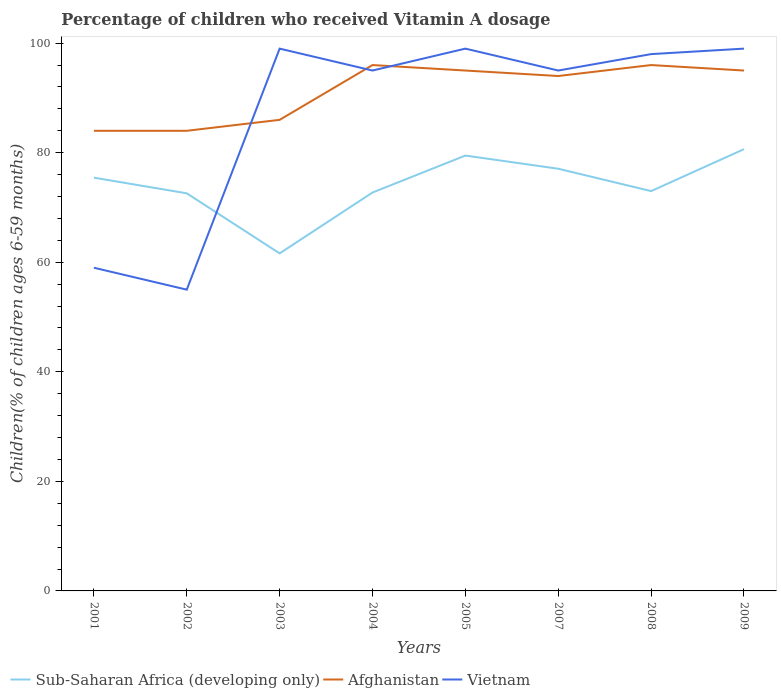How many different coloured lines are there?
Provide a short and direct response. 3. Is the number of lines equal to the number of legend labels?
Your answer should be compact. Yes. Across all years, what is the maximum percentage of children who received Vitamin A dosage in Vietnam?
Make the answer very short. 55. What is the total percentage of children who received Vitamin A dosage in Sub-Saharan Africa (developing only) in the graph?
Keep it short and to the point. -4.34. What is the difference between the highest and the second highest percentage of children who received Vitamin A dosage in Vietnam?
Your answer should be very brief. 44. Is the percentage of children who received Vitamin A dosage in Afghanistan strictly greater than the percentage of children who received Vitamin A dosage in Vietnam over the years?
Offer a very short reply. No. What is the difference between two consecutive major ticks on the Y-axis?
Your answer should be very brief. 20. What is the title of the graph?
Your response must be concise. Percentage of children who received Vitamin A dosage. What is the label or title of the X-axis?
Offer a very short reply. Years. What is the label or title of the Y-axis?
Ensure brevity in your answer.  Children(% of children ages 6-59 months). What is the Children(% of children ages 6-59 months) in Sub-Saharan Africa (developing only) in 2001?
Offer a very short reply. 75.44. What is the Children(% of children ages 6-59 months) of Afghanistan in 2001?
Provide a short and direct response. 84. What is the Children(% of children ages 6-59 months) in Vietnam in 2001?
Make the answer very short. 59. What is the Children(% of children ages 6-59 months) of Sub-Saharan Africa (developing only) in 2002?
Your answer should be compact. 72.58. What is the Children(% of children ages 6-59 months) of Sub-Saharan Africa (developing only) in 2003?
Your answer should be compact. 61.62. What is the Children(% of children ages 6-59 months) of Sub-Saharan Africa (developing only) in 2004?
Give a very brief answer. 72.73. What is the Children(% of children ages 6-59 months) in Afghanistan in 2004?
Offer a very short reply. 96. What is the Children(% of children ages 6-59 months) of Vietnam in 2004?
Ensure brevity in your answer.  95. What is the Children(% of children ages 6-59 months) in Sub-Saharan Africa (developing only) in 2005?
Your response must be concise. 79.48. What is the Children(% of children ages 6-59 months) of Sub-Saharan Africa (developing only) in 2007?
Keep it short and to the point. 77.07. What is the Children(% of children ages 6-59 months) in Afghanistan in 2007?
Give a very brief answer. 94. What is the Children(% of children ages 6-59 months) in Sub-Saharan Africa (developing only) in 2008?
Ensure brevity in your answer.  72.99. What is the Children(% of children ages 6-59 months) in Afghanistan in 2008?
Keep it short and to the point. 96. What is the Children(% of children ages 6-59 months) in Sub-Saharan Africa (developing only) in 2009?
Offer a very short reply. 80.65. What is the Children(% of children ages 6-59 months) of Afghanistan in 2009?
Your answer should be very brief. 95. What is the Children(% of children ages 6-59 months) of Vietnam in 2009?
Your response must be concise. 99. Across all years, what is the maximum Children(% of children ages 6-59 months) in Sub-Saharan Africa (developing only)?
Offer a very short reply. 80.65. Across all years, what is the maximum Children(% of children ages 6-59 months) in Afghanistan?
Ensure brevity in your answer.  96. Across all years, what is the minimum Children(% of children ages 6-59 months) of Sub-Saharan Africa (developing only)?
Your answer should be compact. 61.62. Across all years, what is the minimum Children(% of children ages 6-59 months) of Vietnam?
Offer a very short reply. 55. What is the total Children(% of children ages 6-59 months) of Sub-Saharan Africa (developing only) in the graph?
Provide a succinct answer. 592.56. What is the total Children(% of children ages 6-59 months) in Afghanistan in the graph?
Make the answer very short. 730. What is the total Children(% of children ages 6-59 months) of Vietnam in the graph?
Offer a terse response. 699. What is the difference between the Children(% of children ages 6-59 months) of Sub-Saharan Africa (developing only) in 2001 and that in 2002?
Give a very brief answer. 2.86. What is the difference between the Children(% of children ages 6-59 months) in Sub-Saharan Africa (developing only) in 2001 and that in 2003?
Your answer should be very brief. 13.83. What is the difference between the Children(% of children ages 6-59 months) in Sub-Saharan Africa (developing only) in 2001 and that in 2004?
Provide a short and direct response. 2.71. What is the difference between the Children(% of children ages 6-59 months) of Afghanistan in 2001 and that in 2004?
Your answer should be compact. -12. What is the difference between the Children(% of children ages 6-59 months) in Vietnam in 2001 and that in 2004?
Provide a succinct answer. -36. What is the difference between the Children(% of children ages 6-59 months) in Sub-Saharan Africa (developing only) in 2001 and that in 2005?
Offer a terse response. -4.03. What is the difference between the Children(% of children ages 6-59 months) in Afghanistan in 2001 and that in 2005?
Your response must be concise. -11. What is the difference between the Children(% of children ages 6-59 months) in Sub-Saharan Africa (developing only) in 2001 and that in 2007?
Keep it short and to the point. -1.63. What is the difference between the Children(% of children ages 6-59 months) in Afghanistan in 2001 and that in 2007?
Make the answer very short. -10. What is the difference between the Children(% of children ages 6-59 months) in Vietnam in 2001 and that in 2007?
Offer a terse response. -36. What is the difference between the Children(% of children ages 6-59 months) of Sub-Saharan Africa (developing only) in 2001 and that in 2008?
Ensure brevity in your answer.  2.45. What is the difference between the Children(% of children ages 6-59 months) in Vietnam in 2001 and that in 2008?
Provide a succinct answer. -39. What is the difference between the Children(% of children ages 6-59 months) in Sub-Saharan Africa (developing only) in 2001 and that in 2009?
Your response must be concise. -5.2. What is the difference between the Children(% of children ages 6-59 months) of Vietnam in 2001 and that in 2009?
Your answer should be compact. -40. What is the difference between the Children(% of children ages 6-59 months) in Sub-Saharan Africa (developing only) in 2002 and that in 2003?
Your answer should be very brief. 10.96. What is the difference between the Children(% of children ages 6-59 months) of Vietnam in 2002 and that in 2003?
Offer a terse response. -44. What is the difference between the Children(% of children ages 6-59 months) of Sub-Saharan Africa (developing only) in 2002 and that in 2004?
Your response must be concise. -0.15. What is the difference between the Children(% of children ages 6-59 months) of Sub-Saharan Africa (developing only) in 2002 and that in 2005?
Give a very brief answer. -6.9. What is the difference between the Children(% of children ages 6-59 months) in Afghanistan in 2002 and that in 2005?
Your response must be concise. -11. What is the difference between the Children(% of children ages 6-59 months) of Vietnam in 2002 and that in 2005?
Your answer should be compact. -44. What is the difference between the Children(% of children ages 6-59 months) of Sub-Saharan Africa (developing only) in 2002 and that in 2007?
Your answer should be very brief. -4.49. What is the difference between the Children(% of children ages 6-59 months) of Afghanistan in 2002 and that in 2007?
Offer a very short reply. -10. What is the difference between the Children(% of children ages 6-59 months) of Vietnam in 2002 and that in 2007?
Provide a short and direct response. -40. What is the difference between the Children(% of children ages 6-59 months) of Sub-Saharan Africa (developing only) in 2002 and that in 2008?
Keep it short and to the point. -0.41. What is the difference between the Children(% of children ages 6-59 months) of Vietnam in 2002 and that in 2008?
Offer a very short reply. -43. What is the difference between the Children(% of children ages 6-59 months) in Sub-Saharan Africa (developing only) in 2002 and that in 2009?
Make the answer very short. -8.06. What is the difference between the Children(% of children ages 6-59 months) in Vietnam in 2002 and that in 2009?
Keep it short and to the point. -44. What is the difference between the Children(% of children ages 6-59 months) of Sub-Saharan Africa (developing only) in 2003 and that in 2004?
Provide a short and direct response. -11.11. What is the difference between the Children(% of children ages 6-59 months) in Afghanistan in 2003 and that in 2004?
Make the answer very short. -10. What is the difference between the Children(% of children ages 6-59 months) in Sub-Saharan Africa (developing only) in 2003 and that in 2005?
Keep it short and to the point. -17.86. What is the difference between the Children(% of children ages 6-59 months) of Vietnam in 2003 and that in 2005?
Your response must be concise. 0. What is the difference between the Children(% of children ages 6-59 months) in Sub-Saharan Africa (developing only) in 2003 and that in 2007?
Provide a short and direct response. -15.45. What is the difference between the Children(% of children ages 6-59 months) of Afghanistan in 2003 and that in 2007?
Ensure brevity in your answer.  -8. What is the difference between the Children(% of children ages 6-59 months) of Sub-Saharan Africa (developing only) in 2003 and that in 2008?
Your answer should be very brief. -11.37. What is the difference between the Children(% of children ages 6-59 months) of Afghanistan in 2003 and that in 2008?
Offer a very short reply. -10. What is the difference between the Children(% of children ages 6-59 months) in Sub-Saharan Africa (developing only) in 2003 and that in 2009?
Provide a short and direct response. -19.03. What is the difference between the Children(% of children ages 6-59 months) in Vietnam in 2003 and that in 2009?
Offer a terse response. 0. What is the difference between the Children(% of children ages 6-59 months) of Sub-Saharan Africa (developing only) in 2004 and that in 2005?
Offer a terse response. -6.75. What is the difference between the Children(% of children ages 6-59 months) of Afghanistan in 2004 and that in 2005?
Keep it short and to the point. 1. What is the difference between the Children(% of children ages 6-59 months) of Vietnam in 2004 and that in 2005?
Your response must be concise. -4. What is the difference between the Children(% of children ages 6-59 months) of Sub-Saharan Africa (developing only) in 2004 and that in 2007?
Keep it short and to the point. -4.34. What is the difference between the Children(% of children ages 6-59 months) in Afghanistan in 2004 and that in 2007?
Give a very brief answer. 2. What is the difference between the Children(% of children ages 6-59 months) in Sub-Saharan Africa (developing only) in 2004 and that in 2008?
Your answer should be very brief. -0.26. What is the difference between the Children(% of children ages 6-59 months) in Vietnam in 2004 and that in 2008?
Your response must be concise. -3. What is the difference between the Children(% of children ages 6-59 months) of Sub-Saharan Africa (developing only) in 2004 and that in 2009?
Your response must be concise. -7.92. What is the difference between the Children(% of children ages 6-59 months) of Vietnam in 2004 and that in 2009?
Provide a short and direct response. -4. What is the difference between the Children(% of children ages 6-59 months) of Sub-Saharan Africa (developing only) in 2005 and that in 2007?
Your answer should be very brief. 2.41. What is the difference between the Children(% of children ages 6-59 months) in Vietnam in 2005 and that in 2007?
Keep it short and to the point. 4. What is the difference between the Children(% of children ages 6-59 months) of Sub-Saharan Africa (developing only) in 2005 and that in 2008?
Your answer should be compact. 6.49. What is the difference between the Children(% of children ages 6-59 months) of Afghanistan in 2005 and that in 2008?
Your answer should be compact. -1. What is the difference between the Children(% of children ages 6-59 months) in Sub-Saharan Africa (developing only) in 2005 and that in 2009?
Provide a succinct answer. -1.17. What is the difference between the Children(% of children ages 6-59 months) of Sub-Saharan Africa (developing only) in 2007 and that in 2008?
Ensure brevity in your answer.  4.08. What is the difference between the Children(% of children ages 6-59 months) in Afghanistan in 2007 and that in 2008?
Ensure brevity in your answer.  -2. What is the difference between the Children(% of children ages 6-59 months) in Sub-Saharan Africa (developing only) in 2007 and that in 2009?
Offer a very short reply. -3.58. What is the difference between the Children(% of children ages 6-59 months) of Vietnam in 2007 and that in 2009?
Offer a terse response. -4. What is the difference between the Children(% of children ages 6-59 months) of Sub-Saharan Africa (developing only) in 2008 and that in 2009?
Offer a terse response. -7.66. What is the difference between the Children(% of children ages 6-59 months) of Afghanistan in 2008 and that in 2009?
Your response must be concise. 1. What is the difference between the Children(% of children ages 6-59 months) of Vietnam in 2008 and that in 2009?
Your answer should be compact. -1. What is the difference between the Children(% of children ages 6-59 months) in Sub-Saharan Africa (developing only) in 2001 and the Children(% of children ages 6-59 months) in Afghanistan in 2002?
Ensure brevity in your answer.  -8.56. What is the difference between the Children(% of children ages 6-59 months) of Sub-Saharan Africa (developing only) in 2001 and the Children(% of children ages 6-59 months) of Vietnam in 2002?
Provide a succinct answer. 20.44. What is the difference between the Children(% of children ages 6-59 months) of Afghanistan in 2001 and the Children(% of children ages 6-59 months) of Vietnam in 2002?
Ensure brevity in your answer.  29. What is the difference between the Children(% of children ages 6-59 months) in Sub-Saharan Africa (developing only) in 2001 and the Children(% of children ages 6-59 months) in Afghanistan in 2003?
Ensure brevity in your answer.  -10.56. What is the difference between the Children(% of children ages 6-59 months) of Sub-Saharan Africa (developing only) in 2001 and the Children(% of children ages 6-59 months) of Vietnam in 2003?
Your answer should be compact. -23.56. What is the difference between the Children(% of children ages 6-59 months) of Afghanistan in 2001 and the Children(% of children ages 6-59 months) of Vietnam in 2003?
Ensure brevity in your answer.  -15. What is the difference between the Children(% of children ages 6-59 months) of Sub-Saharan Africa (developing only) in 2001 and the Children(% of children ages 6-59 months) of Afghanistan in 2004?
Your answer should be compact. -20.56. What is the difference between the Children(% of children ages 6-59 months) in Sub-Saharan Africa (developing only) in 2001 and the Children(% of children ages 6-59 months) in Vietnam in 2004?
Offer a terse response. -19.56. What is the difference between the Children(% of children ages 6-59 months) of Sub-Saharan Africa (developing only) in 2001 and the Children(% of children ages 6-59 months) of Afghanistan in 2005?
Your answer should be very brief. -19.56. What is the difference between the Children(% of children ages 6-59 months) in Sub-Saharan Africa (developing only) in 2001 and the Children(% of children ages 6-59 months) in Vietnam in 2005?
Keep it short and to the point. -23.56. What is the difference between the Children(% of children ages 6-59 months) in Sub-Saharan Africa (developing only) in 2001 and the Children(% of children ages 6-59 months) in Afghanistan in 2007?
Offer a very short reply. -18.56. What is the difference between the Children(% of children ages 6-59 months) of Sub-Saharan Africa (developing only) in 2001 and the Children(% of children ages 6-59 months) of Vietnam in 2007?
Your response must be concise. -19.56. What is the difference between the Children(% of children ages 6-59 months) of Afghanistan in 2001 and the Children(% of children ages 6-59 months) of Vietnam in 2007?
Offer a terse response. -11. What is the difference between the Children(% of children ages 6-59 months) of Sub-Saharan Africa (developing only) in 2001 and the Children(% of children ages 6-59 months) of Afghanistan in 2008?
Offer a terse response. -20.56. What is the difference between the Children(% of children ages 6-59 months) in Sub-Saharan Africa (developing only) in 2001 and the Children(% of children ages 6-59 months) in Vietnam in 2008?
Offer a terse response. -22.56. What is the difference between the Children(% of children ages 6-59 months) of Sub-Saharan Africa (developing only) in 2001 and the Children(% of children ages 6-59 months) of Afghanistan in 2009?
Keep it short and to the point. -19.56. What is the difference between the Children(% of children ages 6-59 months) in Sub-Saharan Africa (developing only) in 2001 and the Children(% of children ages 6-59 months) in Vietnam in 2009?
Offer a terse response. -23.56. What is the difference between the Children(% of children ages 6-59 months) in Sub-Saharan Africa (developing only) in 2002 and the Children(% of children ages 6-59 months) in Afghanistan in 2003?
Make the answer very short. -13.42. What is the difference between the Children(% of children ages 6-59 months) of Sub-Saharan Africa (developing only) in 2002 and the Children(% of children ages 6-59 months) of Vietnam in 2003?
Provide a short and direct response. -26.42. What is the difference between the Children(% of children ages 6-59 months) of Afghanistan in 2002 and the Children(% of children ages 6-59 months) of Vietnam in 2003?
Offer a terse response. -15. What is the difference between the Children(% of children ages 6-59 months) of Sub-Saharan Africa (developing only) in 2002 and the Children(% of children ages 6-59 months) of Afghanistan in 2004?
Your answer should be compact. -23.42. What is the difference between the Children(% of children ages 6-59 months) of Sub-Saharan Africa (developing only) in 2002 and the Children(% of children ages 6-59 months) of Vietnam in 2004?
Your answer should be compact. -22.42. What is the difference between the Children(% of children ages 6-59 months) in Sub-Saharan Africa (developing only) in 2002 and the Children(% of children ages 6-59 months) in Afghanistan in 2005?
Ensure brevity in your answer.  -22.42. What is the difference between the Children(% of children ages 6-59 months) of Sub-Saharan Africa (developing only) in 2002 and the Children(% of children ages 6-59 months) of Vietnam in 2005?
Make the answer very short. -26.42. What is the difference between the Children(% of children ages 6-59 months) of Afghanistan in 2002 and the Children(% of children ages 6-59 months) of Vietnam in 2005?
Your answer should be compact. -15. What is the difference between the Children(% of children ages 6-59 months) in Sub-Saharan Africa (developing only) in 2002 and the Children(% of children ages 6-59 months) in Afghanistan in 2007?
Your answer should be very brief. -21.42. What is the difference between the Children(% of children ages 6-59 months) of Sub-Saharan Africa (developing only) in 2002 and the Children(% of children ages 6-59 months) of Vietnam in 2007?
Provide a succinct answer. -22.42. What is the difference between the Children(% of children ages 6-59 months) in Sub-Saharan Africa (developing only) in 2002 and the Children(% of children ages 6-59 months) in Afghanistan in 2008?
Offer a terse response. -23.42. What is the difference between the Children(% of children ages 6-59 months) of Sub-Saharan Africa (developing only) in 2002 and the Children(% of children ages 6-59 months) of Vietnam in 2008?
Make the answer very short. -25.42. What is the difference between the Children(% of children ages 6-59 months) of Sub-Saharan Africa (developing only) in 2002 and the Children(% of children ages 6-59 months) of Afghanistan in 2009?
Provide a short and direct response. -22.42. What is the difference between the Children(% of children ages 6-59 months) in Sub-Saharan Africa (developing only) in 2002 and the Children(% of children ages 6-59 months) in Vietnam in 2009?
Provide a succinct answer. -26.42. What is the difference between the Children(% of children ages 6-59 months) of Sub-Saharan Africa (developing only) in 2003 and the Children(% of children ages 6-59 months) of Afghanistan in 2004?
Provide a succinct answer. -34.38. What is the difference between the Children(% of children ages 6-59 months) in Sub-Saharan Africa (developing only) in 2003 and the Children(% of children ages 6-59 months) in Vietnam in 2004?
Offer a terse response. -33.38. What is the difference between the Children(% of children ages 6-59 months) in Afghanistan in 2003 and the Children(% of children ages 6-59 months) in Vietnam in 2004?
Provide a succinct answer. -9. What is the difference between the Children(% of children ages 6-59 months) in Sub-Saharan Africa (developing only) in 2003 and the Children(% of children ages 6-59 months) in Afghanistan in 2005?
Keep it short and to the point. -33.38. What is the difference between the Children(% of children ages 6-59 months) of Sub-Saharan Africa (developing only) in 2003 and the Children(% of children ages 6-59 months) of Vietnam in 2005?
Provide a short and direct response. -37.38. What is the difference between the Children(% of children ages 6-59 months) of Sub-Saharan Africa (developing only) in 2003 and the Children(% of children ages 6-59 months) of Afghanistan in 2007?
Your answer should be very brief. -32.38. What is the difference between the Children(% of children ages 6-59 months) in Sub-Saharan Africa (developing only) in 2003 and the Children(% of children ages 6-59 months) in Vietnam in 2007?
Your answer should be very brief. -33.38. What is the difference between the Children(% of children ages 6-59 months) of Afghanistan in 2003 and the Children(% of children ages 6-59 months) of Vietnam in 2007?
Ensure brevity in your answer.  -9. What is the difference between the Children(% of children ages 6-59 months) in Sub-Saharan Africa (developing only) in 2003 and the Children(% of children ages 6-59 months) in Afghanistan in 2008?
Make the answer very short. -34.38. What is the difference between the Children(% of children ages 6-59 months) in Sub-Saharan Africa (developing only) in 2003 and the Children(% of children ages 6-59 months) in Vietnam in 2008?
Provide a succinct answer. -36.38. What is the difference between the Children(% of children ages 6-59 months) of Afghanistan in 2003 and the Children(% of children ages 6-59 months) of Vietnam in 2008?
Give a very brief answer. -12. What is the difference between the Children(% of children ages 6-59 months) in Sub-Saharan Africa (developing only) in 2003 and the Children(% of children ages 6-59 months) in Afghanistan in 2009?
Offer a terse response. -33.38. What is the difference between the Children(% of children ages 6-59 months) in Sub-Saharan Africa (developing only) in 2003 and the Children(% of children ages 6-59 months) in Vietnam in 2009?
Keep it short and to the point. -37.38. What is the difference between the Children(% of children ages 6-59 months) in Afghanistan in 2003 and the Children(% of children ages 6-59 months) in Vietnam in 2009?
Your answer should be compact. -13. What is the difference between the Children(% of children ages 6-59 months) of Sub-Saharan Africa (developing only) in 2004 and the Children(% of children ages 6-59 months) of Afghanistan in 2005?
Your answer should be compact. -22.27. What is the difference between the Children(% of children ages 6-59 months) of Sub-Saharan Africa (developing only) in 2004 and the Children(% of children ages 6-59 months) of Vietnam in 2005?
Make the answer very short. -26.27. What is the difference between the Children(% of children ages 6-59 months) in Afghanistan in 2004 and the Children(% of children ages 6-59 months) in Vietnam in 2005?
Your answer should be very brief. -3. What is the difference between the Children(% of children ages 6-59 months) in Sub-Saharan Africa (developing only) in 2004 and the Children(% of children ages 6-59 months) in Afghanistan in 2007?
Provide a succinct answer. -21.27. What is the difference between the Children(% of children ages 6-59 months) in Sub-Saharan Africa (developing only) in 2004 and the Children(% of children ages 6-59 months) in Vietnam in 2007?
Ensure brevity in your answer.  -22.27. What is the difference between the Children(% of children ages 6-59 months) of Afghanistan in 2004 and the Children(% of children ages 6-59 months) of Vietnam in 2007?
Your answer should be very brief. 1. What is the difference between the Children(% of children ages 6-59 months) of Sub-Saharan Africa (developing only) in 2004 and the Children(% of children ages 6-59 months) of Afghanistan in 2008?
Your answer should be compact. -23.27. What is the difference between the Children(% of children ages 6-59 months) of Sub-Saharan Africa (developing only) in 2004 and the Children(% of children ages 6-59 months) of Vietnam in 2008?
Your answer should be very brief. -25.27. What is the difference between the Children(% of children ages 6-59 months) of Sub-Saharan Africa (developing only) in 2004 and the Children(% of children ages 6-59 months) of Afghanistan in 2009?
Ensure brevity in your answer.  -22.27. What is the difference between the Children(% of children ages 6-59 months) in Sub-Saharan Africa (developing only) in 2004 and the Children(% of children ages 6-59 months) in Vietnam in 2009?
Your answer should be very brief. -26.27. What is the difference between the Children(% of children ages 6-59 months) in Sub-Saharan Africa (developing only) in 2005 and the Children(% of children ages 6-59 months) in Afghanistan in 2007?
Provide a succinct answer. -14.52. What is the difference between the Children(% of children ages 6-59 months) in Sub-Saharan Africa (developing only) in 2005 and the Children(% of children ages 6-59 months) in Vietnam in 2007?
Your answer should be compact. -15.52. What is the difference between the Children(% of children ages 6-59 months) in Sub-Saharan Africa (developing only) in 2005 and the Children(% of children ages 6-59 months) in Afghanistan in 2008?
Offer a very short reply. -16.52. What is the difference between the Children(% of children ages 6-59 months) in Sub-Saharan Africa (developing only) in 2005 and the Children(% of children ages 6-59 months) in Vietnam in 2008?
Offer a very short reply. -18.52. What is the difference between the Children(% of children ages 6-59 months) in Afghanistan in 2005 and the Children(% of children ages 6-59 months) in Vietnam in 2008?
Provide a short and direct response. -3. What is the difference between the Children(% of children ages 6-59 months) in Sub-Saharan Africa (developing only) in 2005 and the Children(% of children ages 6-59 months) in Afghanistan in 2009?
Your response must be concise. -15.52. What is the difference between the Children(% of children ages 6-59 months) in Sub-Saharan Africa (developing only) in 2005 and the Children(% of children ages 6-59 months) in Vietnam in 2009?
Ensure brevity in your answer.  -19.52. What is the difference between the Children(% of children ages 6-59 months) of Sub-Saharan Africa (developing only) in 2007 and the Children(% of children ages 6-59 months) of Afghanistan in 2008?
Provide a succinct answer. -18.93. What is the difference between the Children(% of children ages 6-59 months) of Sub-Saharan Africa (developing only) in 2007 and the Children(% of children ages 6-59 months) of Vietnam in 2008?
Your response must be concise. -20.93. What is the difference between the Children(% of children ages 6-59 months) of Afghanistan in 2007 and the Children(% of children ages 6-59 months) of Vietnam in 2008?
Ensure brevity in your answer.  -4. What is the difference between the Children(% of children ages 6-59 months) of Sub-Saharan Africa (developing only) in 2007 and the Children(% of children ages 6-59 months) of Afghanistan in 2009?
Keep it short and to the point. -17.93. What is the difference between the Children(% of children ages 6-59 months) of Sub-Saharan Africa (developing only) in 2007 and the Children(% of children ages 6-59 months) of Vietnam in 2009?
Provide a succinct answer. -21.93. What is the difference between the Children(% of children ages 6-59 months) of Afghanistan in 2007 and the Children(% of children ages 6-59 months) of Vietnam in 2009?
Give a very brief answer. -5. What is the difference between the Children(% of children ages 6-59 months) in Sub-Saharan Africa (developing only) in 2008 and the Children(% of children ages 6-59 months) in Afghanistan in 2009?
Keep it short and to the point. -22.01. What is the difference between the Children(% of children ages 6-59 months) in Sub-Saharan Africa (developing only) in 2008 and the Children(% of children ages 6-59 months) in Vietnam in 2009?
Offer a very short reply. -26.01. What is the difference between the Children(% of children ages 6-59 months) of Afghanistan in 2008 and the Children(% of children ages 6-59 months) of Vietnam in 2009?
Offer a terse response. -3. What is the average Children(% of children ages 6-59 months) of Sub-Saharan Africa (developing only) per year?
Make the answer very short. 74.07. What is the average Children(% of children ages 6-59 months) of Afghanistan per year?
Provide a succinct answer. 91.25. What is the average Children(% of children ages 6-59 months) in Vietnam per year?
Keep it short and to the point. 87.38. In the year 2001, what is the difference between the Children(% of children ages 6-59 months) in Sub-Saharan Africa (developing only) and Children(% of children ages 6-59 months) in Afghanistan?
Keep it short and to the point. -8.56. In the year 2001, what is the difference between the Children(% of children ages 6-59 months) in Sub-Saharan Africa (developing only) and Children(% of children ages 6-59 months) in Vietnam?
Make the answer very short. 16.44. In the year 2002, what is the difference between the Children(% of children ages 6-59 months) in Sub-Saharan Africa (developing only) and Children(% of children ages 6-59 months) in Afghanistan?
Provide a short and direct response. -11.42. In the year 2002, what is the difference between the Children(% of children ages 6-59 months) in Sub-Saharan Africa (developing only) and Children(% of children ages 6-59 months) in Vietnam?
Keep it short and to the point. 17.58. In the year 2003, what is the difference between the Children(% of children ages 6-59 months) in Sub-Saharan Africa (developing only) and Children(% of children ages 6-59 months) in Afghanistan?
Your response must be concise. -24.38. In the year 2003, what is the difference between the Children(% of children ages 6-59 months) of Sub-Saharan Africa (developing only) and Children(% of children ages 6-59 months) of Vietnam?
Your answer should be very brief. -37.38. In the year 2004, what is the difference between the Children(% of children ages 6-59 months) of Sub-Saharan Africa (developing only) and Children(% of children ages 6-59 months) of Afghanistan?
Give a very brief answer. -23.27. In the year 2004, what is the difference between the Children(% of children ages 6-59 months) in Sub-Saharan Africa (developing only) and Children(% of children ages 6-59 months) in Vietnam?
Ensure brevity in your answer.  -22.27. In the year 2005, what is the difference between the Children(% of children ages 6-59 months) in Sub-Saharan Africa (developing only) and Children(% of children ages 6-59 months) in Afghanistan?
Make the answer very short. -15.52. In the year 2005, what is the difference between the Children(% of children ages 6-59 months) in Sub-Saharan Africa (developing only) and Children(% of children ages 6-59 months) in Vietnam?
Provide a succinct answer. -19.52. In the year 2005, what is the difference between the Children(% of children ages 6-59 months) of Afghanistan and Children(% of children ages 6-59 months) of Vietnam?
Make the answer very short. -4. In the year 2007, what is the difference between the Children(% of children ages 6-59 months) in Sub-Saharan Africa (developing only) and Children(% of children ages 6-59 months) in Afghanistan?
Provide a short and direct response. -16.93. In the year 2007, what is the difference between the Children(% of children ages 6-59 months) in Sub-Saharan Africa (developing only) and Children(% of children ages 6-59 months) in Vietnam?
Ensure brevity in your answer.  -17.93. In the year 2008, what is the difference between the Children(% of children ages 6-59 months) in Sub-Saharan Africa (developing only) and Children(% of children ages 6-59 months) in Afghanistan?
Ensure brevity in your answer.  -23.01. In the year 2008, what is the difference between the Children(% of children ages 6-59 months) of Sub-Saharan Africa (developing only) and Children(% of children ages 6-59 months) of Vietnam?
Your answer should be compact. -25.01. In the year 2009, what is the difference between the Children(% of children ages 6-59 months) in Sub-Saharan Africa (developing only) and Children(% of children ages 6-59 months) in Afghanistan?
Provide a short and direct response. -14.35. In the year 2009, what is the difference between the Children(% of children ages 6-59 months) in Sub-Saharan Africa (developing only) and Children(% of children ages 6-59 months) in Vietnam?
Your answer should be compact. -18.35. In the year 2009, what is the difference between the Children(% of children ages 6-59 months) in Afghanistan and Children(% of children ages 6-59 months) in Vietnam?
Keep it short and to the point. -4. What is the ratio of the Children(% of children ages 6-59 months) of Sub-Saharan Africa (developing only) in 2001 to that in 2002?
Provide a short and direct response. 1.04. What is the ratio of the Children(% of children ages 6-59 months) of Afghanistan in 2001 to that in 2002?
Provide a succinct answer. 1. What is the ratio of the Children(% of children ages 6-59 months) in Vietnam in 2001 to that in 2002?
Provide a short and direct response. 1.07. What is the ratio of the Children(% of children ages 6-59 months) of Sub-Saharan Africa (developing only) in 2001 to that in 2003?
Your response must be concise. 1.22. What is the ratio of the Children(% of children ages 6-59 months) of Afghanistan in 2001 to that in 2003?
Your answer should be very brief. 0.98. What is the ratio of the Children(% of children ages 6-59 months) in Vietnam in 2001 to that in 2003?
Your answer should be very brief. 0.6. What is the ratio of the Children(% of children ages 6-59 months) of Sub-Saharan Africa (developing only) in 2001 to that in 2004?
Your answer should be very brief. 1.04. What is the ratio of the Children(% of children ages 6-59 months) in Afghanistan in 2001 to that in 2004?
Your answer should be very brief. 0.88. What is the ratio of the Children(% of children ages 6-59 months) in Vietnam in 2001 to that in 2004?
Your response must be concise. 0.62. What is the ratio of the Children(% of children ages 6-59 months) in Sub-Saharan Africa (developing only) in 2001 to that in 2005?
Your answer should be compact. 0.95. What is the ratio of the Children(% of children ages 6-59 months) in Afghanistan in 2001 to that in 2005?
Your answer should be very brief. 0.88. What is the ratio of the Children(% of children ages 6-59 months) of Vietnam in 2001 to that in 2005?
Your answer should be very brief. 0.6. What is the ratio of the Children(% of children ages 6-59 months) of Sub-Saharan Africa (developing only) in 2001 to that in 2007?
Provide a short and direct response. 0.98. What is the ratio of the Children(% of children ages 6-59 months) in Afghanistan in 2001 to that in 2007?
Give a very brief answer. 0.89. What is the ratio of the Children(% of children ages 6-59 months) in Vietnam in 2001 to that in 2007?
Provide a succinct answer. 0.62. What is the ratio of the Children(% of children ages 6-59 months) in Sub-Saharan Africa (developing only) in 2001 to that in 2008?
Offer a terse response. 1.03. What is the ratio of the Children(% of children ages 6-59 months) in Afghanistan in 2001 to that in 2008?
Provide a short and direct response. 0.88. What is the ratio of the Children(% of children ages 6-59 months) in Vietnam in 2001 to that in 2008?
Provide a short and direct response. 0.6. What is the ratio of the Children(% of children ages 6-59 months) in Sub-Saharan Africa (developing only) in 2001 to that in 2009?
Provide a short and direct response. 0.94. What is the ratio of the Children(% of children ages 6-59 months) in Afghanistan in 2001 to that in 2009?
Provide a succinct answer. 0.88. What is the ratio of the Children(% of children ages 6-59 months) in Vietnam in 2001 to that in 2009?
Make the answer very short. 0.6. What is the ratio of the Children(% of children ages 6-59 months) in Sub-Saharan Africa (developing only) in 2002 to that in 2003?
Your answer should be compact. 1.18. What is the ratio of the Children(% of children ages 6-59 months) in Afghanistan in 2002 to that in 2003?
Provide a short and direct response. 0.98. What is the ratio of the Children(% of children ages 6-59 months) in Vietnam in 2002 to that in 2003?
Your answer should be compact. 0.56. What is the ratio of the Children(% of children ages 6-59 months) in Vietnam in 2002 to that in 2004?
Provide a succinct answer. 0.58. What is the ratio of the Children(% of children ages 6-59 months) of Sub-Saharan Africa (developing only) in 2002 to that in 2005?
Provide a short and direct response. 0.91. What is the ratio of the Children(% of children ages 6-59 months) in Afghanistan in 2002 to that in 2005?
Provide a succinct answer. 0.88. What is the ratio of the Children(% of children ages 6-59 months) of Vietnam in 2002 to that in 2005?
Provide a succinct answer. 0.56. What is the ratio of the Children(% of children ages 6-59 months) of Sub-Saharan Africa (developing only) in 2002 to that in 2007?
Keep it short and to the point. 0.94. What is the ratio of the Children(% of children ages 6-59 months) of Afghanistan in 2002 to that in 2007?
Your answer should be very brief. 0.89. What is the ratio of the Children(% of children ages 6-59 months) of Vietnam in 2002 to that in 2007?
Offer a terse response. 0.58. What is the ratio of the Children(% of children ages 6-59 months) in Vietnam in 2002 to that in 2008?
Keep it short and to the point. 0.56. What is the ratio of the Children(% of children ages 6-59 months) of Sub-Saharan Africa (developing only) in 2002 to that in 2009?
Give a very brief answer. 0.9. What is the ratio of the Children(% of children ages 6-59 months) in Afghanistan in 2002 to that in 2009?
Your answer should be very brief. 0.88. What is the ratio of the Children(% of children ages 6-59 months) in Vietnam in 2002 to that in 2009?
Your answer should be compact. 0.56. What is the ratio of the Children(% of children ages 6-59 months) in Sub-Saharan Africa (developing only) in 2003 to that in 2004?
Ensure brevity in your answer.  0.85. What is the ratio of the Children(% of children ages 6-59 months) in Afghanistan in 2003 to that in 2004?
Your answer should be compact. 0.9. What is the ratio of the Children(% of children ages 6-59 months) in Vietnam in 2003 to that in 2004?
Make the answer very short. 1.04. What is the ratio of the Children(% of children ages 6-59 months) in Sub-Saharan Africa (developing only) in 2003 to that in 2005?
Your answer should be compact. 0.78. What is the ratio of the Children(% of children ages 6-59 months) of Afghanistan in 2003 to that in 2005?
Offer a very short reply. 0.91. What is the ratio of the Children(% of children ages 6-59 months) in Sub-Saharan Africa (developing only) in 2003 to that in 2007?
Provide a short and direct response. 0.8. What is the ratio of the Children(% of children ages 6-59 months) of Afghanistan in 2003 to that in 2007?
Provide a succinct answer. 0.91. What is the ratio of the Children(% of children ages 6-59 months) of Vietnam in 2003 to that in 2007?
Your answer should be very brief. 1.04. What is the ratio of the Children(% of children ages 6-59 months) of Sub-Saharan Africa (developing only) in 2003 to that in 2008?
Ensure brevity in your answer.  0.84. What is the ratio of the Children(% of children ages 6-59 months) in Afghanistan in 2003 to that in 2008?
Provide a succinct answer. 0.9. What is the ratio of the Children(% of children ages 6-59 months) in Vietnam in 2003 to that in 2008?
Keep it short and to the point. 1.01. What is the ratio of the Children(% of children ages 6-59 months) in Sub-Saharan Africa (developing only) in 2003 to that in 2009?
Offer a very short reply. 0.76. What is the ratio of the Children(% of children ages 6-59 months) in Afghanistan in 2003 to that in 2009?
Your response must be concise. 0.91. What is the ratio of the Children(% of children ages 6-59 months) of Sub-Saharan Africa (developing only) in 2004 to that in 2005?
Your answer should be very brief. 0.92. What is the ratio of the Children(% of children ages 6-59 months) of Afghanistan in 2004 to that in 2005?
Your response must be concise. 1.01. What is the ratio of the Children(% of children ages 6-59 months) in Vietnam in 2004 to that in 2005?
Give a very brief answer. 0.96. What is the ratio of the Children(% of children ages 6-59 months) in Sub-Saharan Africa (developing only) in 2004 to that in 2007?
Keep it short and to the point. 0.94. What is the ratio of the Children(% of children ages 6-59 months) in Afghanistan in 2004 to that in 2007?
Your answer should be very brief. 1.02. What is the ratio of the Children(% of children ages 6-59 months) in Vietnam in 2004 to that in 2007?
Your answer should be very brief. 1. What is the ratio of the Children(% of children ages 6-59 months) in Sub-Saharan Africa (developing only) in 2004 to that in 2008?
Offer a terse response. 1. What is the ratio of the Children(% of children ages 6-59 months) of Afghanistan in 2004 to that in 2008?
Give a very brief answer. 1. What is the ratio of the Children(% of children ages 6-59 months) of Vietnam in 2004 to that in 2008?
Your response must be concise. 0.97. What is the ratio of the Children(% of children ages 6-59 months) in Sub-Saharan Africa (developing only) in 2004 to that in 2009?
Your response must be concise. 0.9. What is the ratio of the Children(% of children ages 6-59 months) in Afghanistan in 2004 to that in 2009?
Ensure brevity in your answer.  1.01. What is the ratio of the Children(% of children ages 6-59 months) in Vietnam in 2004 to that in 2009?
Offer a very short reply. 0.96. What is the ratio of the Children(% of children ages 6-59 months) in Sub-Saharan Africa (developing only) in 2005 to that in 2007?
Your answer should be compact. 1.03. What is the ratio of the Children(% of children ages 6-59 months) in Afghanistan in 2005 to that in 2007?
Offer a very short reply. 1.01. What is the ratio of the Children(% of children ages 6-59 months) of Vietnam in 2005 to that in 2007?
Offer a very short reply. 1.04. What is the ratio of the Children(% of children ages 6-59 months) in Sub-Saharan Africa (developing only) in 2005 to that in 2008?
Provide a succinct answer. 1.09. What is the ratio of the Children(% of children ages 6-59 months) of Afghanistan in 2005 to that in 2008?
Ensure brevity in your answer.  0.99. What is the ratio of the Children(% of children ages 6-59 months) of Vietnam in 2005 to that in 2008?
Ensure brevity in your answer.  1.01. What is the ratio of the Children(% of children ages 6-59 months) in Sub-Saharan Africa (developing only) in 2005 to that in 2009?
Provide a succinct answer. 0.99. What is the ratio of the Children(% of children ages 6-59 months) of Afghanistan in 2005 to that in 2009?
Your answer should be compact. 1. What is the ratio of the Children(% of children ages 6-59 months) of Vietnam in 2005 to that in 2009?
Ensure brevity in your answer.  1. What is the ratio of the Children(% of children ages 6-59 months) of Sub-Saharan Africa (developing only) in 2007 to that in 2008?
Offer a very short reply. 1.06. What is the ratio of the Children(% of children ages 6-59 months) of Afghanistan in 2007 to that in 2008?
Your response must be concise. 0.98. What is the ratio of the Children(% of children ages 6-59 months) in Vietnam in 2007 to that in 2008?
Offer a terse response. 0.97. What is the ratio of the Children(% of children ages 6-59 months) of Sub-Saharan Africa (developing only) in 2007 to that in 2009?
Provide a short and direct response. 0.96. What is the ratio of the Children(% of children ages 6-59 months) of Afghanistan in 2007 to that in 2009?
Make the answer very short. 0.99. What is the ratio of the Children(% of children ages 6-59 months) in Vietnam in 2007 to that in 2009?
Provide a succinct answer. 0.96. What is the ratio of the Children(% of children ages 6-59 months) of Sub-Saharan Africa (developing only) in 2008 to that in 2009?
Offer a very short reply. 0.91. What is the ratio of the Children(% of children ages 6-59 months) in Afghanistan in 2008 to that in 2009?
Offer a terse response. 1.01. What is the ratio of the Children(% of children ages 6-59 months) of Vietnam in 2008 to that in 2009?
Your response must be concise. 0.99. What is the difference between the highest and the second highest Children(% of children ages 6-59 months) in Sub-Saharan Africa (developing only)?
Make the answer very short. 1.17. What is the difference between the highest and the lowest Children(% of children ages 6-59 months) in Sub-Saharan Africa (developing only)?
Offer a terse response. 19.03. 